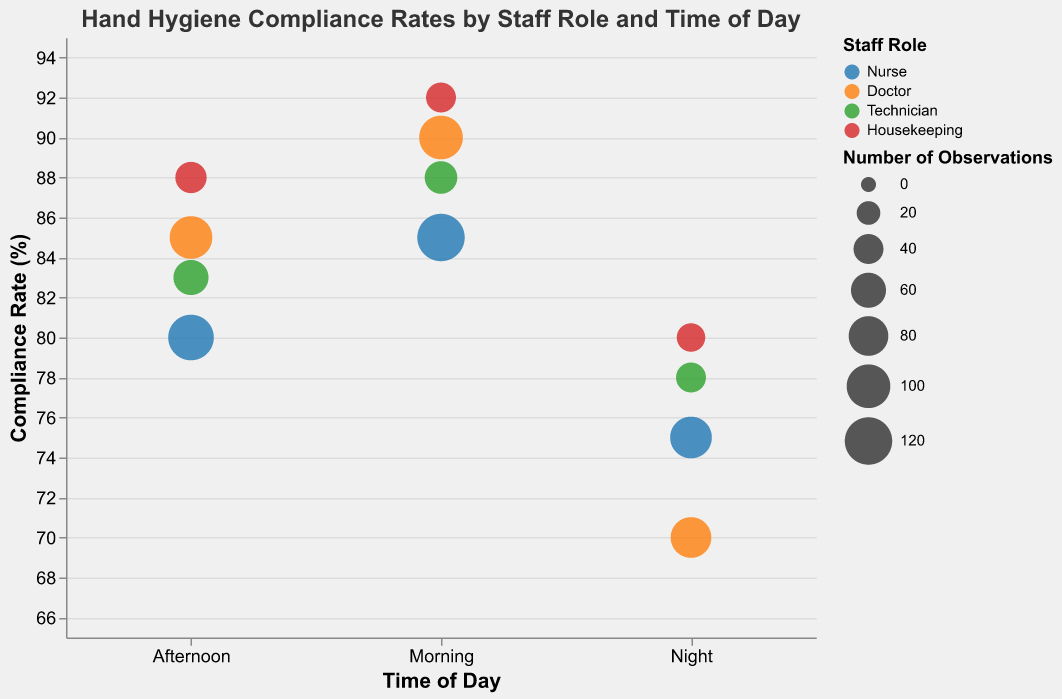What is the title of the bubble chart? The title of the chart is located at the top of the figure, and it summarizes the theme of the data presented in the chart. The title states: "Hand Hygiene Compliance Rates by Staff Role and Time of Day".
Answer: Hand Hygiene Compliance Rates by Staff Role and Time of Day Which staff role has the highest compliance rate in the morning? Look for the bubbles in the "Morning" column and identify the one with the highest position on the y-axis. The bubble representing "Housekeeping" staff is the highest, indicating they have the highest compliance rate.
Answer: Housekeeping Who has the lowest compliance rate at night? Look at the "Night" column and find the bubble located at the lowest position on the y-axis. The bubble representing "Doctor" staff is the lowest, indicating they have the lowest compliance rate.
Answer: Doctor How many observations are there for nurses in the afternoon? The size of the bubble should be checked in the "Afternoon" column corresponding to "Nurse". Hovering over or checking the tooltip reveals that the number of observations is 110.
Answer: 110 Compare the compliance rates between technicians and housekeeping in the morning. Find the bubbles for "Technician" and "Housekeeping" within the "Morning" column, observe their respective y-axis positions (which represent compliance rate). Housekeeping is at 92% and Technician is at 88% compliance rate.
Answer: Housekeeping: 92%, Technician: 88% What is the difference in compliance rates between nurses in the morning and evening? Identify the bubbles for "Nurse" in both the "Morning" and "Night" columns, and subtract the compliance rate of the night (75%) from the morning (85%). 85 - 75 = 10.
Answer: 10% What is the average compliance rate for doctors across all times of the day? Extract the compliance rates for doctors from the morning, afternoon, and night (90%, 85%, and 70% respectively), sum these values and divide by the number of time periods (3). (90 + 85 + 70) / 3 = 81.67.
Answer: 81.67% What is the relationship between the number of observations and the size of the bubbles? Larger bubbles represent more observations. Check the range of sizes on the legend indicating "Number of Observations". Larger bubbles are visually bigger in the legend and the chart.
Answer: Larger bubbles indicate more observations Does the compliance rate for nurses decrease, increase, or stay the same over time? Observe the y-axis positions of the bubbles for "Nurse" across the time of day from morning to night, showing a decrease from 85% (morning) to 80% (afternoon) to 75% (night).
Answer: Decrease Which staff role has the highest overall compliance rates regardless of the time of day? Check the highest bubbles across all time columns. "Housekeeping" has the highest rates consistently, with 92% in the morning, 88% in the afternoon, and 80% at night.
Answer: Housekeeping 